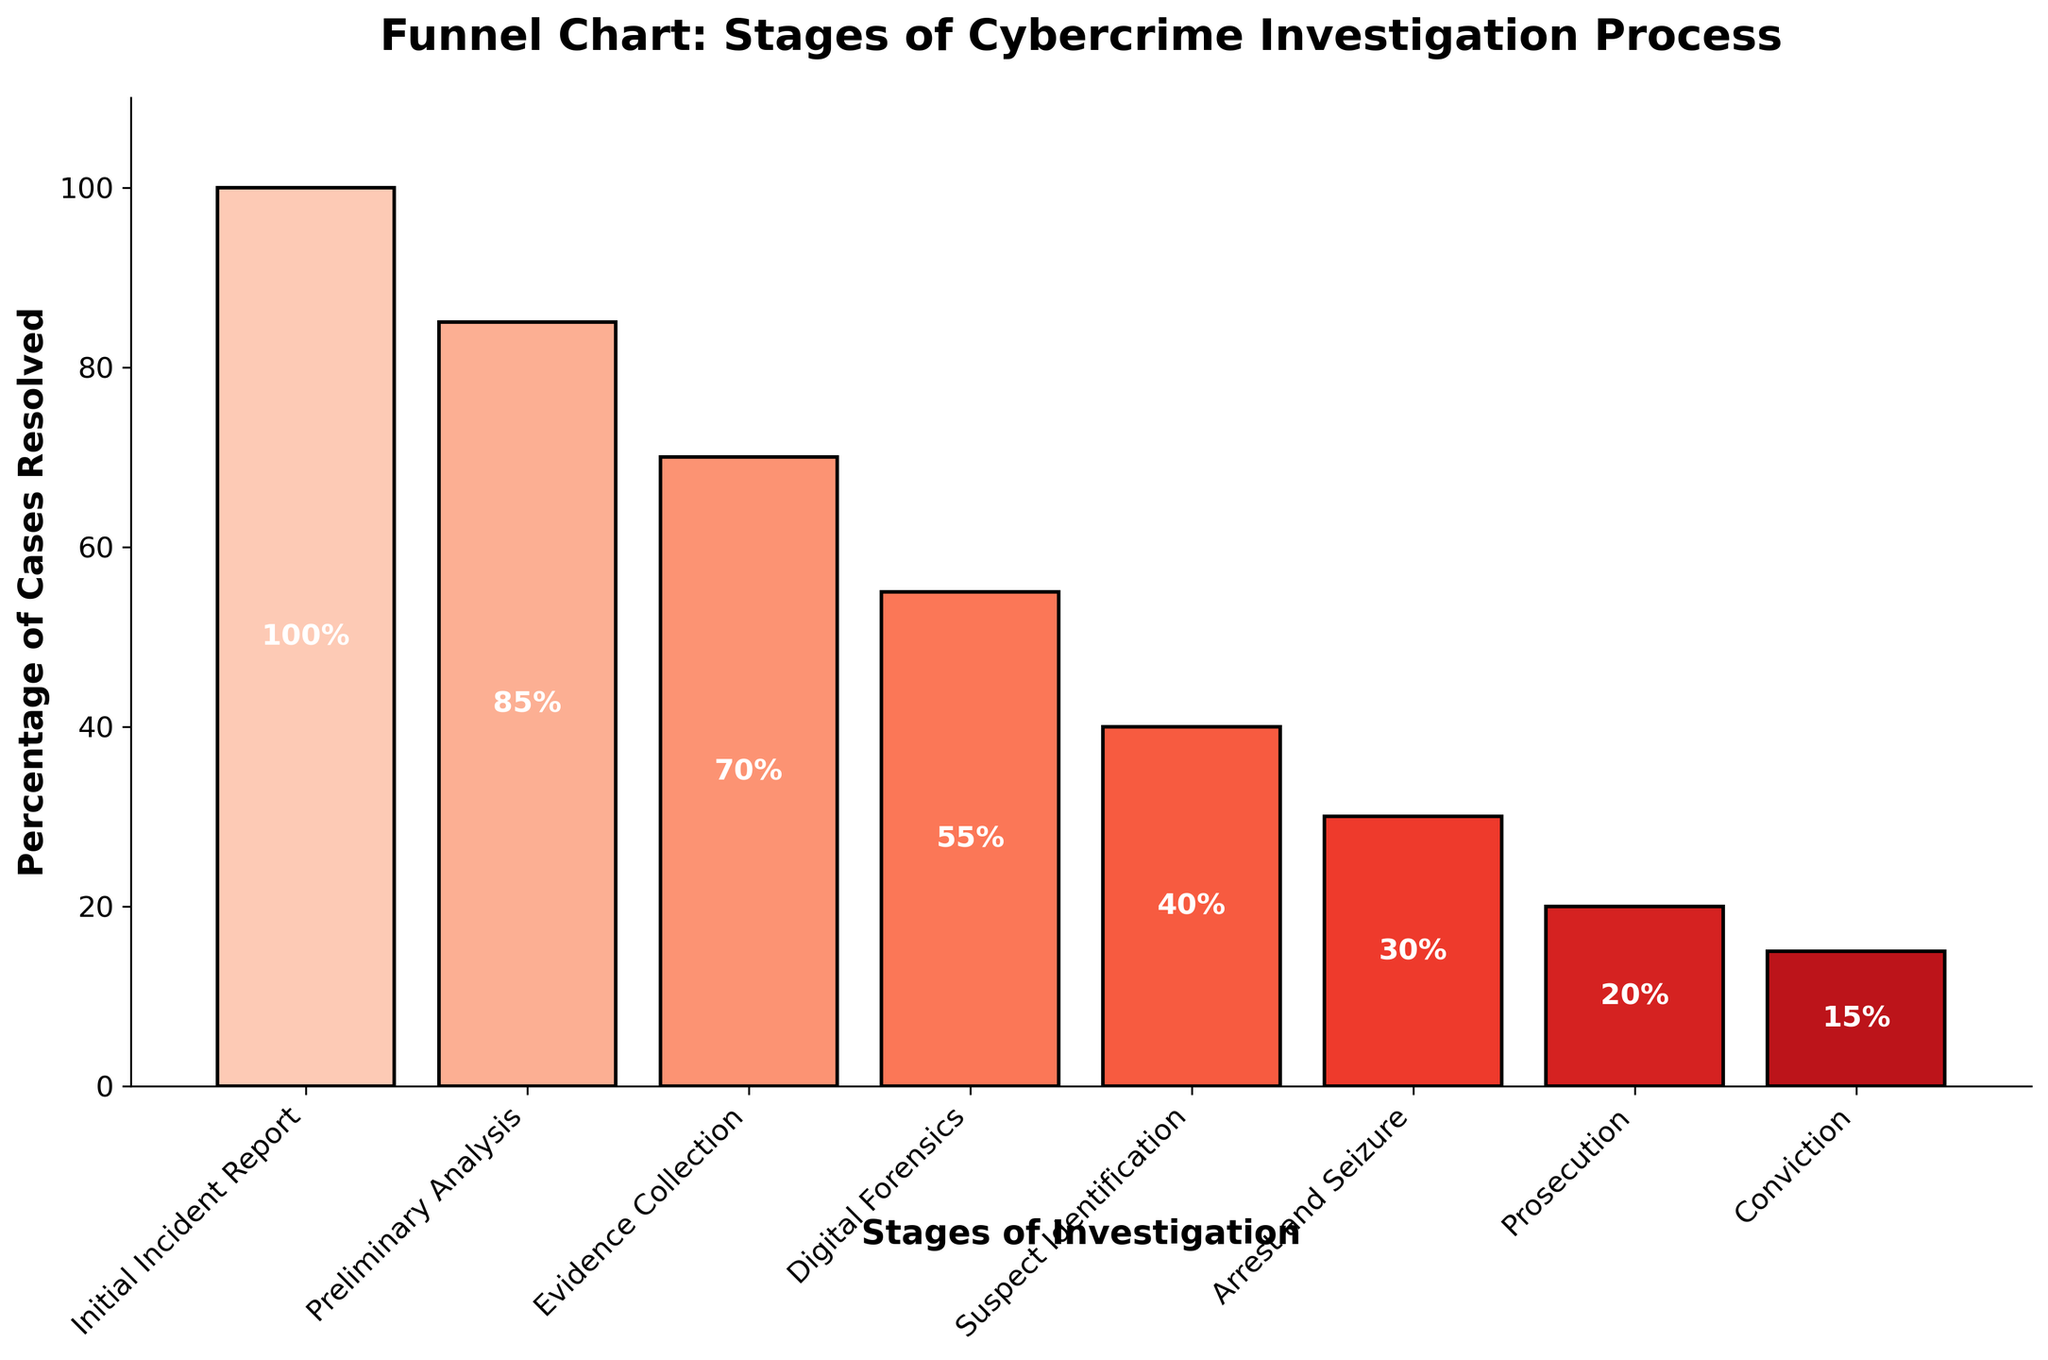what is the title of the figure? The title is located at the top of the figure and reads "Funnel Chart: Stages of Cybercrime Investigation Process".
Answer: Funnel Chart: Stages of Cybercrime Investigation Process how many stages are shown in the figure? The stages are represented by the bars along the x-axis, counting from "Initial Incident Report" to "Conviction", totaling 8 stages.
Answer: 8 which stage has the lowest percentage of cases resolved? By examining the height of the bars, the "Conviction" stage has the lowest percentage at 15%.
Answer: Conviction by how much percentage does the "Digital Forensics" stage decrease compared to the "Evidence Collection" stage? The "Evidence Collection" stage is at 70% and the "Digital Forensics" stage is at 55%, so the decrease is 70% - 55% = 15%.
Answer: 15% what is the average percentage of cases resolved across all stages? Adding up all percentages: 100% + 85% + 70% + 55% + 40% + 30% + 20% + 15% = 415%. Dividing by the number of stages, 8, gives an average of 415%/8 = 51.875%.
Answer: 51.875% which stage shows a significant drop from its previous stage and by how much? The "Suspect Identification" stage drops to 40% from 55% at the "Digital Forensics" stage, a decrease of 55% - 40% = 15%.
Answer: Suspect Identification, 15% which stage has a resolution rate of less than 25%? The stages with resolution rates shown on the y-axis are "Prosecution" at 20% and "Conviction" at 15%.
Answer: Prosecution, Conviction is the drop in percentages greater from "Preliminary Analysis" to "Evidence Collection" or from "Suspect Identification" to "Arrest and Seizure"? The drop from "Preliminary Analysis" (85%) to "Evidence Collection" (70%) is 85% - 70% = 15%. The drop from "Suspect Identification" (40%) to "Arrest and Seizure" (30%) is 40% - 30% = 10%.
Answer: Preliminary Analysis to Evidence Collection, 15% calculate the total percentage decrease from "Initial Incident Report" to "Conviction". The decrease from "Initial Incident Report" (100%) to "Conviction" (15%) is 100% - 15% = 85%.
Answer: 85% 